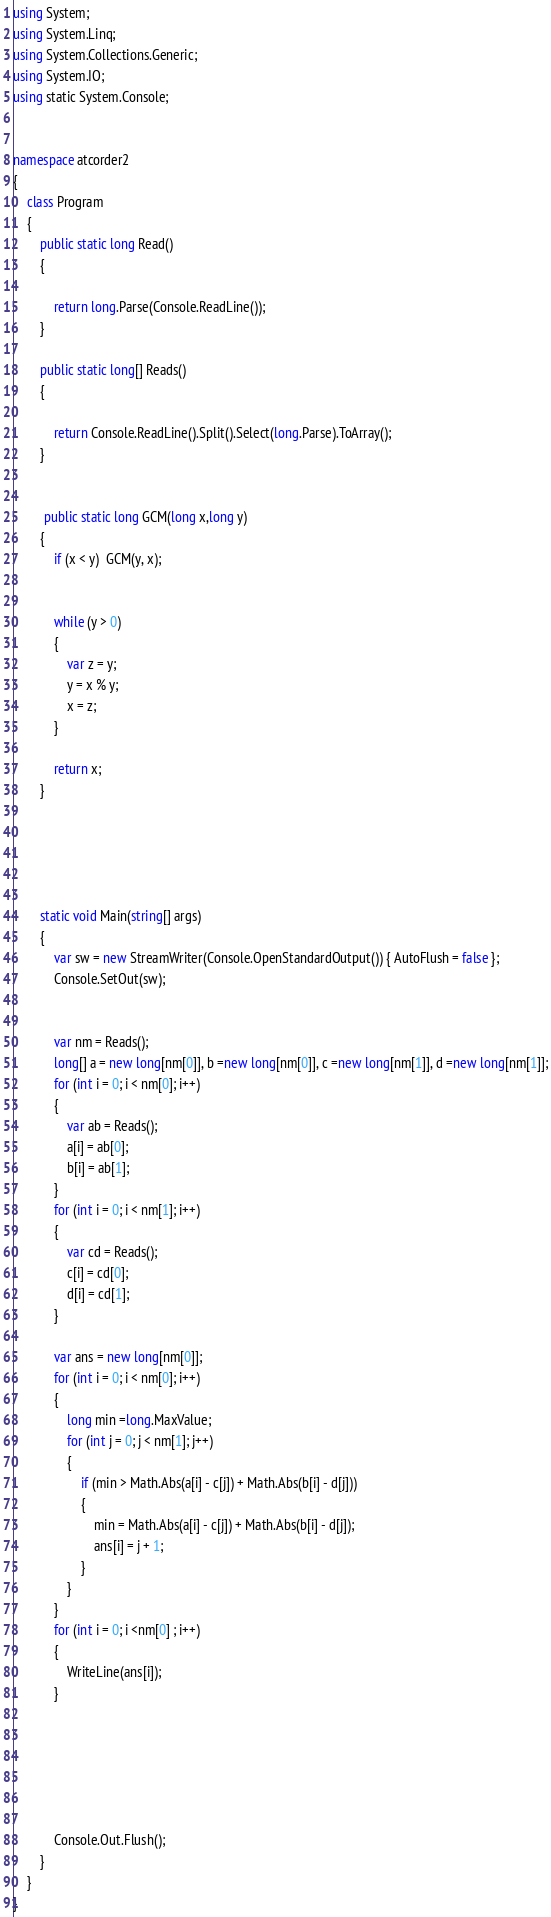<code> <loc_0><loc_0><loc_500><loc_500><_C#_>using System;
using System.Linq;
using System.Collections.Generic;
using System.IO;
using static System.Console;


namespace atcorder2
{
    class Program
    {
        public static long Read()
        {

            return long.Parse(Console.ReadLine());
        }

        public static long[] Reads()
        {

            return Console.ReadLine().Split().Select(long.Parse).ToArray();
        }

       
         public static long GCM(long x,long y)
        {
            if (x < y)  GCM(y, x);


            while (y > 0)
            {
                var z = y;
                y = x % y;
                x = z;
            }
            
            return x;
        }

        



        static void Main(string[] args)
        {
            var sw = new StreamWriter(Console.OpenStandardOutput()) { AutoFlush = false };
            Console.SetOut(sw);


            var nm = Reads();
            long[] a = new long[nm[0]], b =new long[nm[0]], c =new long[nm[1]], d =new long[nm[1]];
            for (int i = 0; i < nm[0]; i++)
            {
                var ab = Reads();
                a[i] = ab[0];
                b[i] = ab[1];
            }
            for (int i = 0; i < nm[1]; i++)
            {
                var cd = Reads();
                c[i] = cd[0];
                d[i] = cd[1];
            }

            var ans = new long[nm[0]];
            for (int i = 0; i < nm[0]; i++)
            {
                long min =long.MaxValue;
                for (int j = 0; j < nm[1]; j++)
                {
                    if (min > Math.Abs(a[i] - c[j]) + Math.Abs(b[i] - d[j]))
                    {
                        min = Math.Abs(a[i] - c[j]) + Math.Abs(b[i] - d[j]);
                        ans[i] = j + 1;
                    }
                }
            }
            for (int i = 0; i <nm[0] ; i++)
            {
                WriteLine(ans[i]);
            }






            Console.Out.Flush();
        }
    }
}


</code> 